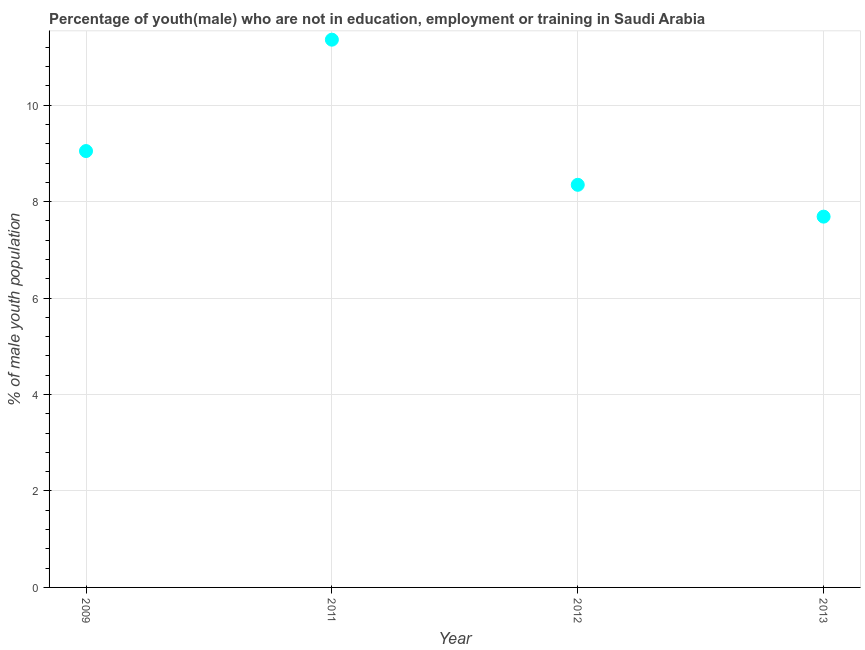What is the unemployed male youth population in 2013?
Make the answer very short. 7.69. Across all years, what is the maximum unemployed male youth population?
Keep it short and to the point. 11.36. Across all years, what is the minimum unemployed male youth population?
Give a very brief answer. 7.69. In which year was the unemployed male youth population minimum?
Your answer should be very brief. 2013. What is the sum of the unemployed male youth population?
Provide a succinct answer. 36.45. What is the difference between the unemployed male youth population in 2012 and 2013?
Offer a very short reply. 0.66. What is the average unemployed male youth population per year?
Make the answer very short. 9.11. What is the median unemployed male youth population?
Your response must be concise. 8.7. In how many years, is the unemployed male youth population greater than 0.4 %?
Provide a short and direct response. 4. What is the ratio of the unemployed male youth population in 2009 to that in 2011?
Your answer should be very brief. 0.8. Is the unemployed male youth population in 2011 less than that in 2012?
Your answer should be very brief. No. Is the difference between the unemployed male youth population in 2011 and 2012 greater than the difference between any two years?
Give a very brief answer. No. What is the difference between the highest and the second highest unemployed male youth population?
Offer a very short reply. 2.31. Is the sum of the unemployed male youth population in 2011 and 2012 greater than the maximum unemployed male youth population across all years?
Provide a succinct answer. Yes. What is the difference between the highest and the lowest unemployed male youth population?
Provide a succinct answer. 3.67. In how many years, is the unemployed male youth population greater than the average unemployed male youth population taken over all years?
Your answer should be compact. 1. Does the unemployed male youth population monotonically increase over the years?
Keep it short and to the point. No. How many years are there in the graph?
Make the answer very short. 4. What is the difference between two consecutive major ticks on the Y-axis?
Give a very brief answer. 2. What is the title of the graph?
Provide a succinct answer. Percentage of youth(male) who are not in education, employment or training in Saudi Arabia. What is the label or title of the X-axis?
Ensure brevity in your answer.  Year. What is the label or title of the Y-axis?
Make the answer very short. % of male youth population. What is the % of male youth population in 2009?
Keep it short and to the point. 9.05. What is the % of male youth population in 2011?
Provide a succinct answer. 11.36. What is the % of male youth population in 2012?
Keep it short and to the point. 8.35. What is the % of male youth population in 2013?
Offer a very short reply. 7.69. What is the difference between the % of male youth population in 2009 and 2011?
Keep it short and to the point. -2.31. What is the difference between the % of male youth population in 2009 and 2013?
Your answer should be compact. 1.36. What is the difference between the % of male youth population in 2011 and 2012?
Offer a very short reply. 3.01. What is the difference between the % of male youth population in 2011 and 2013?
Your answer should be compact. 3.67. What is the difference between the % of male youth population in 2012 and 2013?
Ensure brevity in your answer.  0.66. What is the ratio of the % of male youth population in 2009 to that in 2011?
Your response must be concise. 0.8. What is the ratio of the % of male youth population in 2009 to that in 2012?
Your answer should be compact. 1.08. What is the ratio of the % of male youth population in 2009 to that in 2013?
Your answer should be compact. 1.18. What is the ratio of the % of male youth population in 2011 to that in 2012?
Provide a succinct answer. 1.36. What is the ratio of the % of male youth population in 2011 to that in 2013?
Your answer should be very brief. 1.48. What is the ratio of the % of male youth population in 2012 to that in 2013?
Keep it short and to the point. 1.09. 